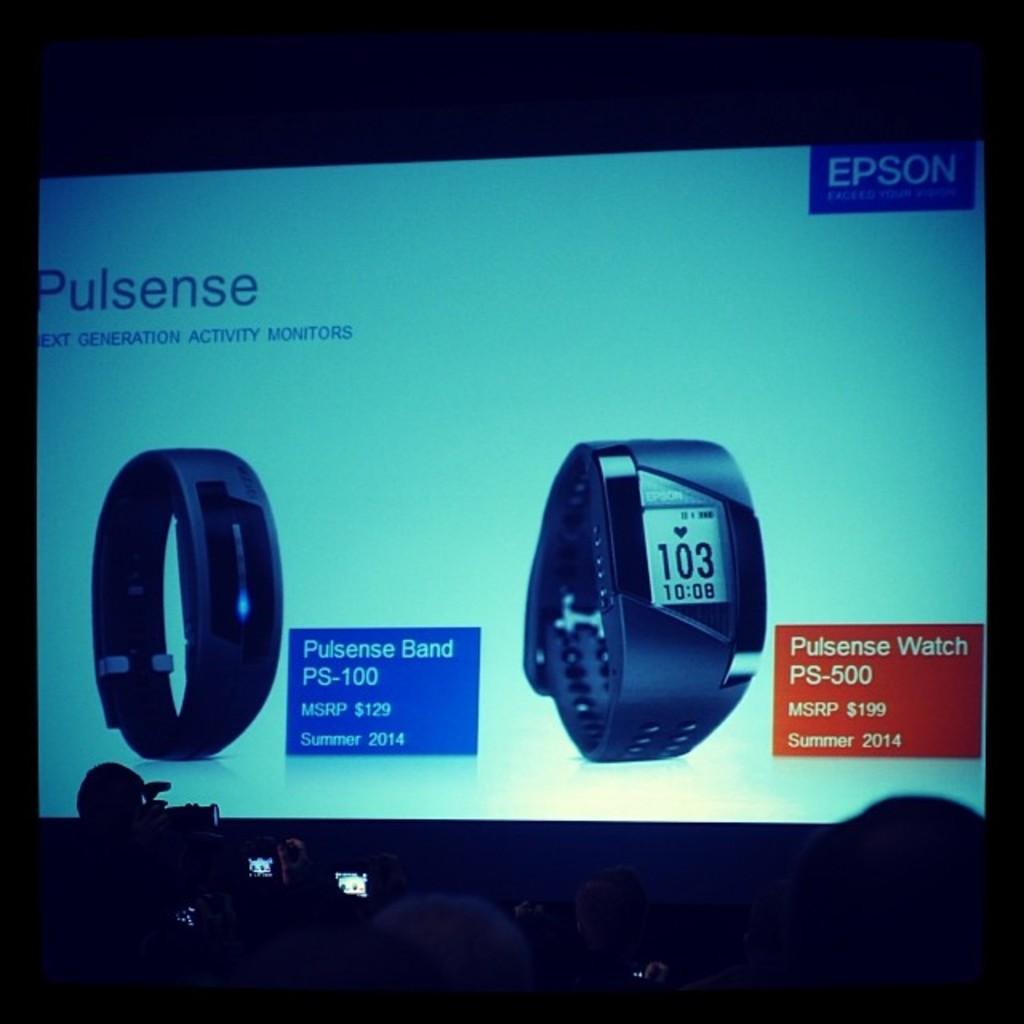How much is the -500 watch?
Ensure brevity in your answer.  199. What number is on the watch?
Your answer should be compact. 103. 